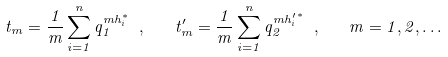<formula> <loc_0><loc_0><loc_500><loc_500>t _ { m } = \frac { 1 } { m } \sum _ { i = 1 } ^ { n } q _ { 1 } ^ { m h _ { i } ^ { * } } \ , \quad t _ { m } ^ { \prime } = \frac { 1 } { m } \sum _ { i = 1 } ^ { n } q _ { 2 } ^ { { m h _ { i } ^ { \prime } } ^ { * } } \ , \quad m = 1 , 2 , \dots</formula> 